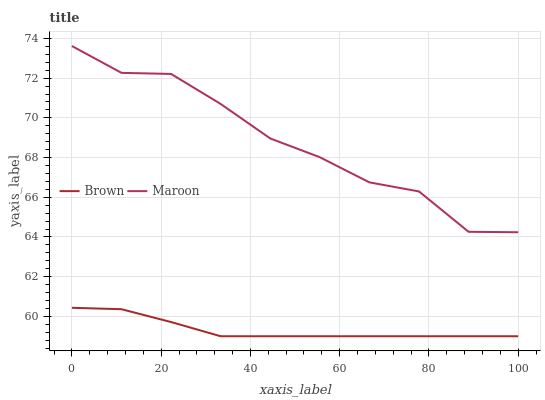Does Brown have the minimum area under the curve?
Answer yes or no. Yes. Does Maroon have the maximum area under the curve?
Answer yes or no. Yes. Does Maroon have the minimum area under the curve?
Answer yes or no. No. Is Brown the smoothest?
Answer yes or no. Yes. Is Maroon the roughest?
Answer yes or no. Yes. Is Maroon the smoothest?
Answer yes or no. No. Does Maroon have the lowest value?
Answer yes or no. No. Does Maroon have the highest value?
Answer yes or no. Yes. Is Brown less than Maroon?
Answer yes or no. Yes. Is Maroon greater than Brown?
Answer yes or no. Yes. Does Brown intersect Maroon?
Answer yes or no. No. 